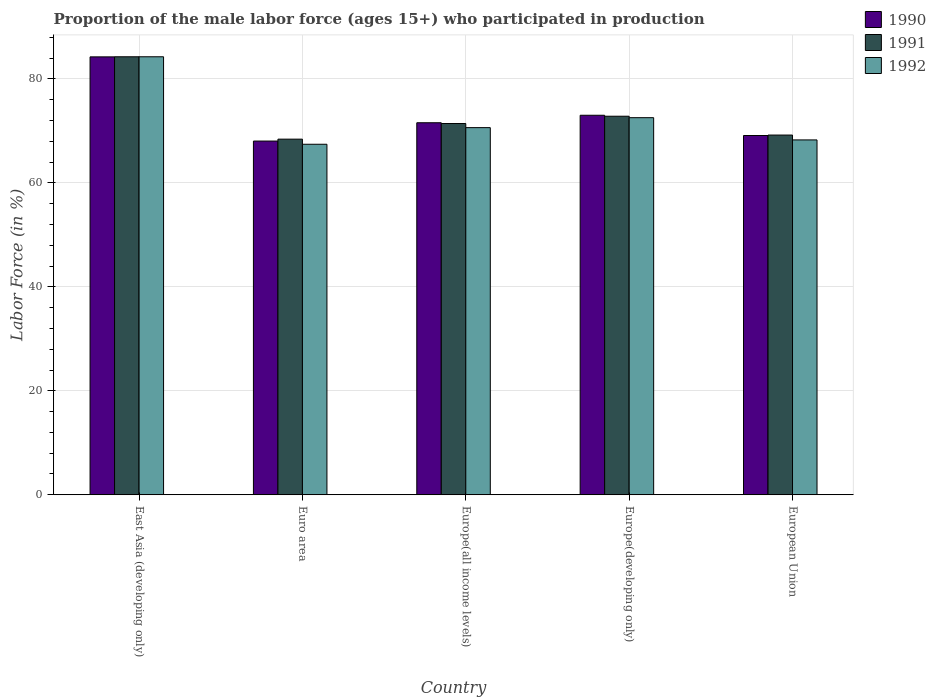How many groups of bars are there?
Your answer should be very brief. 5. How many bars are there on the 2nd tick from the left?
Offer a terse response. 3. What is the label of the 5th group of bars from the left?
Give a very brief answer. European Union. In how many cases, is the number of bars for a given country not equal to the number of legend labels?
Keep it short and to the point. 0. What is the proportion of the male labor force who participated in production in 1990 in Europe(all income levels)?
Provide a succinct answer. 71.56. Across all countries, what is the maximum proportion of the male labor force who participated in production in 1990?
Make the answer very short. 84.23. Across all countries, what is the minimum proportion of the male labor force who participated in production in 1992?
Offer a terse response. 67.42. In which country was the proportion of the male labor force who participated in production in 1990 maximum?
Your answer should be compact. East Asia (developing only). What is the total proportion of the male labor force who participated in production in 1991 in the graph?
Make the answer very short. 366.07. What is the difference between the proportion of the male labor force who participated in production in 1991 in Euro area and that in European Union?
Provide a short and direct response. -0.79. What is the difference between the proportion of the male labor force who participated in production in 1992 in East Asia (developing only) and the proportion of the male labor force who participated in production in 1990 in Euro area?
Your response must be concise. 16.21. What is the average proportion of the male labor force who participated in production in 1992 per country?
Ensure brevity in your answer.  72.62. What is the difference between the proportion of the male labor force who participated in production of/in 1990 and proportion of the male labor force who participated in production of/in 1992 in European Union?
Offer a very short reply. 0.85. In how many countries, is the proportion of the male labor force who participated in production in 1991 greater than 76 %?
Give a very brief answer. 1. What is the ratio of the proportion of the male labor force who participated in production in 1992 in East Asia (developing only) to that in Europe(all income levels)?
Your response must be concise. 1.19. What is the difference between the highest and the second highest proportion of the male labor force who participated in production in 1990?
Your response must be concise. -11.23. What is the difference between the highest and the lowest proportion of the male labor force who participated in production in 1992?
Offer a very short reply. 16.83. In how many countries, is the proportion of the male labor force who participated in production in 1990 greater than the average proportion of the male labor force who participated in production in 1990 taken over all countries?
Give a very brief answer. 1. Is the sum of the proportion of the male labor force who participated in production in 1991 in East Asia (developing only) and Euro area greater than the maximum proportion of the male labor force who participated in production in 1992 across all countries?
Provide a succinct answer. Yes. Is it the case that in every country, the sum of the proportion of the male labor force who participated in production in 1991 and proportion of the male labor force who participated in production in 1992 is greater than the proportion of the male labor force who participated in production in 1990?
Offer a very short reply. Yes. How many bars are there?
Keep it short and to the point. 15. Are all the bars in the graph horizontal?
Offer a terse response. No. What is the difference between two consecutive major ticks on the Y-axis?
Your answer should be compact. 20. Are the values on the major ticks of Y-axis written in scientific E-notation?
Offer a terse response. No. Does the graph contain grids?
Make the answer very short. Yes. How are the legend labels stacked?
Offer a terse response. Vertical. What is the title of the graph?
Offer a very short reply. Proportion of the male labor force (ages 15+) who participated in production. What is the Labor Force (in %) of 1990 in East Asia (developing only)?
Provide a short and direct response. 84.23. What is the Labor Force (in %) of 1991 in East Asia (developing only)?
Offer a very short reply. 84.25. What is the Labor Force (in %) of 1992 in East Asia (developing only)?
Offer a very short reply. 84.25. What is the Labor Force (in %) of 1990 in Euro area?
Offer a very short reply. 68.04. What is the Labor Force (in %) of 1991 in Euro area?
Your answer should be very brief. 68.4. What is the Labor Force (in %) of 1992 in Euro area?
Offer a very short reply. 67.42. What is the Labor Force (in %) of 1990 in Europe(all income levels)?
Offer a very short reply. 71.56. What is the Labor Force (in %) of 1991 in Europe(all income levels)?
Offer a very short reply. 71.41. What is the Labor Force (in %) of 1992 in Europe(all income levels)?
Your answer should be compact. 70.62. What is the Labor Force (in %) of 1990 in Europe(developing only)?
Make the answer very short. 73. What is the Labor Force (in %) of 1991 in Europe(developing only)?
Offer a terse response. 72.82. What is the Labor Force (in %) in 1992 in Europe(developing only)?
Ensure brevity in your answer.  72.53. What is the Labor Force (in %) of 1990 in European Union?
Your response must be concise. 69.1. What is the Labor Force (in %) of 1991 in European Union?
Ensure brevity in your answer.  69.19. What is the Labor Force (in %) in 1992 in European Union?
Give a very brief answer. 68.26. Across all countries, what is the maximum Labor Force (in %) in 1990?
Your response must be concise. 84.23. Across all countries, what is the maximum Labor Force (in %) of 1991?
Offer a terse response. 84.25. Across all countries, what is the maximum Labor Force (in %) in 1992?
Your answer should be compact. 84.25. Across all countries, what is the minimum Labor Force (in %) of 1990?
Offer a very short reply. 68.04. Across all countries, what is the minimum Labor Force (in %) in 1991?
Ensure brevity in your answer.  68.4. Across all countries, what is the minimum Labor Force (in %) of 1992?
Your answer should be compact. 67.42. What is the total Labor Force (in %) in 1990 in the graph?
Provide a short and direct response. 365.94. What is the total Labor Force (in %) in 1991 in the graph?
Your answer should be compact. 366.07. What is the total Labor Force (in %) in 1992 in the graph?
Make the answer very short. 363.09. What is the difference between the Labor Force (in %) in 1990 in East Asia (developing only) and that in Euro area?
Your answer should be very brief. 16.19. What is the difference between the Labor Force (in %) of 1991 in East Asia (developing only) and that in Euro area?
Keep it short and to the point. 15.84. What is the difference between the Labor Force (in %) of 1992 in East Asia (developing only) and that in Euro area?
Give a very brief answer. 16.83. What is the difference between the Labor Force (in %) in 1990 in East Asia (developing only) and that in Europe(all income levels)?
Provide a short and direct response. 12.67. What is the difference between the Labor Force (in %) in 1991 in East Asia (developing only) and that in Europe(all income levels)?
Make the answer very short. 12.84. What is the difference between the Labor Force (in %) in 1992 in East Asia (developing only) and that in Europe(all income levels)?
Offer a terse response. 13.63. What is the difference between the Labor Force (in %) of 1990 in East Asia (developing only) and that in Europe(developing only)?
Offer a terse response. 11.23. What is the difference between the Labor Force (in %) in 1991 in East Asia (developing only) and that in Europe(developing only)?
Your response must be concise. 11.43. What is the difference between the Labor Force (in %) of 1992 in East Asia (developing only) and that in Europe(developing only)?
Offer a very short reply. 11.71. What is the difference between the Labor Force (in %) in 1990 in East Asia (developing only) and that in European Union?
Give a very brief answer. 15.13. What is the difference between the Labor Force (in %) of 1991 in East Asia (developing only) and that in European Union?
Keep it short and to the point. 15.05. What is the difference between the Labor Force (in %) of 1992 in East Asia (developing only) and that in European Union?
Keep it short and to the point. 15.99. What is the difference between the Labor Force (in %) in 1990 in Euro area and that in Europe(all income levels)?
Give a very brief answer. -3.52. What is the difference between the Labor Force (in %) in 1991 in Euro area and that in Europe(all income levels)?
Your answer should be compact. -3. What is the difference between the Labor Force (in %) of 1992 in Euro area and that in Europe(all income levels)?
Provide a short and direct response. -3.2. What is the difference between the Labor Force (in %) of 1990 in Euro area and that in Europe(developing only)?
Your answer should be very brief. -4.96. What is the difference between the Labor Force (in %) of 1991 in Euro area and that in Europe(developing only)?
Provide a succinct answer. -4.41. What is the difference between the Labor Force (in %) in 1992 in Euro area and that in Europe(developing only)?
Keep it short and to the point. -5.11. What is the difference between the Labor Force (in %) of 1990 in Euro area and that in European Union?
Ensure brevity in your answer.  -1.06. What is the difference between the Labor Force (in %) in 1991 in Euro area and that in European Union?
Offer a very short reply. -0.79. What is the difference between the Labor Force (in %) in 1992 in Euro area and that in European Union?
Offer a very short reply. -0.83. What is the difference between the Labor Force (in %) in 1990 in Europe(all income levels) and that in Europe(developing only)?
Keep it short and to the point. -1.44. What is the difference between the Labor Force (in %) in 1991 in Europe(all income levels) and that in Europe(developing only)?
Make the answer very short. -1.41. What is the difference between the Labor Force (in %) of 1992 in Europe(all income levels) and that in Europe(developing only)?
Keep it short and to the point. -1.91. What is the difference between the Labor Force (in %) of 1990 in Europe(all income levels) and that in European Union?
Offer a very short reply. 2.46. What is the difference between the Labor Force (in %) of 1991 in Europe(all income levels) and that in European Union?
Offer a terse response. 2.22. What is the difference between the Labor Force (in %) of 1992 in Europe(all income levels) and that in European Union?
Give a very brief answer. 2.36. What is the difference between the Labor Force (in %) of 1990 in Europe(developing only) and that in European Union?
Give a very brief answer. 3.9. What is the difference between the Labor Force (in %) in 1991 in Europe(developing only) and that in European Union?
Offer a very short reply. 3.62. What is the difference between the Labor Force (in %) of 1992 in Europe(developing only) and that in European Union?
Your answer should be very brief. 4.28. What is the difference between the Labor Force (in %) in 1990 in East Asia (developing only) and the Labor Force (in %) in 1991 in Euro area?
Ensure brevity in your answer.  15.83. What is the difference between the Labor Force (in %) in 1990 in East Asia (developing only) and the Labor Force (in %) in 1992 in Euro area?
Your answer should be very brief. 16.81. What is the difference between the Labor Force (in %) in 1991 in East Asia (developing only) and the Labor Force (in %) in 1992 in Euro area?
Give a very brief answer. 16.82. What is the difference between the Labor Force (in %) of 1990 in East Asia (developing only) and the Labor Force (in %) of 1991 in Europe(all income levels)?
Offer a very short reply. 12.82. What is the difference between the Labor Force (in %) of 1990 in East Asia (developing only) and the Labor Force (in %) of 1992 in Europe(all income levels)?
Offer a very short reply. 13.61. What is the difference between the Labor Force (in %) of 1991 in East Asia (developing only) and the Labor Force (in %) of 1992 in Europe(all income levels)?
Offer a terse response. 13.63. What is the difference between the Labor Force (in %) in 1990 in East Asia (developing only) and the Labor Force (in %) in 1991 in Europe(developing only)?
Offer a terse response. 11.42. What is the difference between the Labor Force (in %) in 1990 in East Asia (developing only) and the Labor Force (in %) in 1992 in Europe(developing only)?
Offer a terse response. 11.7. What is the difference between the Labor Force (in %) of 1991 in East Asia (developing only) and the Labor Force (in %) of 1992 in Europe(developing only)?
Provide a short and direct response. 11.71. What is the difference between the Labor Force (in %) of 1990 in East Asia (developing only) and the Labor Force (in %) of 1991 in European Union?
Ensure brevity in your answer.  15.04. What is the difference between the Labor Force (in %) of 1990 in East Asia (developing only) and the Labor Force (in %) of 1992 in European Union?
Make the answer very short. 15.97. What is the difference between the Labor Force (in %) in 1991 in East Asia (developing only) and the Labor Force (in %) in 1992 in European Union?
Your response must be concise. 15.99. What is the difference between the Labor Force (in %) of 1990 in Euro area and the Labor Force (in %) of 1991 in Europe(all income levels)?
Offer a terse response. -3.37. What is the difference between the Labor Force (in %) of 1990 in Euro area and the Labor Force (in %) of 1992 in Europe(all income levels)?
Provide a succinct answer. -2.58. What is the difference between the Labor Force (in %) in 1991 in Euro area and the Labor Force (in %) in 1992 in Europe(all income levels)?
Your answer should be compact. -2.22. What is the difference between the Labor Force (in %) in 1990 in Euro area and the Labor Force (in %) in 1991 in Europe(developing only)?
Provide a succinct answer. -4.78. What is the difference between the Labor Force (in %) of 1990 in Euro area and the Labor Force (in %) of 1992 in Europe(developing only)?
Your answer should be compact. -4.49. What is the difference between the Labor Force (in %) of 1991 in Euro area and the Labor Force (in %) of 1992 in Europe(developing only)?
Offer a very short reply. -4.13. What is the difference between the Labor Force (in %) in 1990 in Euro area and the Labor Force (in %) in 1991 in European Union?
Provide a succinct answer. -1.15. What is the difference between the Labor Force (in %) in 1990 in Euro area and the Labor Force (in %) in 1992 in European Union?
Offer a terse response. -0.22. What is the difference between the Labor Force (in %) in 1991 in Euro area and the Labor Force (in %) in 1992 in European Union?
Your answer should be very brief. 0.15. What is the difference between the Labor Force (in %) in 1990 in Europe(all income levels) and the Labor Force (in %) in 1991 in Europe(developing only)?
Provide a short and direct response. -1.26. What is the difference between the Labor Force (in %) of 1990 in Europe(all income levels) and the Labor Force (in %) of 1992 in Europe(developing only)?
Your response must be concise. -0.97. What is the difference between the Labor Force (in %) in 1991 in Europe(all income levels) and the Labor Force (in %) in 1992 in Europe(developing only)?
Make the answer very short. -1.12. What is the difference between the Labor Force (in %) in 1990 in Europe(all income levels) and the Labor Force (in %) in 1991 in European Union?
Make the answer very short. 2.37. What is the difference between the Labor Force (in %) of 1990 in Europe(all income levels) and the Labor Force (in %) of 1992 in European Union?
Your response must be concise. 3.3. What is the difference between the Labor Force (in %) in 1991 in Europe(all income levels) and the Labor Force (in %) in 1992 in European Union?
Your response must be concise. 3.15. What is the difference between the Labor Force (in %) in 1990 in Europe(developing only) and the Labor Force (in %) in 1991 in European Union?
Your response must be concise. 3.81. What is the difference between the Labor Force (in %) of 1990 in Europe(developing only) and the Labor Force (in %) of 1992 in European Union?
Your response must be concise. 4.74. What is the difference between the Labor Force (in %) of 1991 in Europe(developing only) and the Labor Force (in %) of 1992 in European Union?
Keep it short and to the point. 4.56. What is the average Labor Force (in %) of 1990 per country?
Your answer should be compact. 73.19. What is the average Labor Force (in %) of 1991 per country?
Keep it short and to the point. 73.21. What is the average Labor Force (in %) of 1992 per country?
Keep it short and to the point. 72.62. What is the difference between the Labor Force (in %) in 1990 and Labor Force (in %) in 1991 in East Asia (developing only)?
Your answer should be compact. -0.02. What is the difference between the Labor Force (in %) of 1990 and Labor Force (in %) of 1992 in East Asia (developing only)?
Your response must be concise. -0.02. What is the difference between the Labor Force (in %) of 1991 and Labor Force (in %) of 1992 in East Asia (developing only)?
Keep it short and to the point. -0. What is the difference between the Labor Force (in %) of 1990 and Labor Force (in %) of 1991 in Euro area?
Make the answer very short. -0.36. What is the difference between the Labor Force (in %) of 1990 and Labor Force (in %) of 1992 in Euro area?
Offer a terse response. 0.62. What is the difference between the Labor Force (in %) of 1991 and Labor Force (in %) of 1992 in Euro area?
Your response must be concise. 0.98. What is the difference between the Labor Force (in %) of 1990 and Labor Force (in %) of 1991 in Europe(all income levels)?
Provide a short and direct response. 0.15. What is the difference between the Labor Force (in %) of 1990 and Labor Force (in %) of 1992 in Europe(all income levels)?
Give a very brief answer. 0.94. What is the difference between the Labor Force (in %) of 1991 and Labor Force (in %) of 1992 in Europe(all income levels)?
Provide a short and direct response. 0.79. What is the difference between the Labor Force (in %) of 1990 and Labor Force (in %) of 1991 in Europe(developing only)?
Offer a terse response. 0.18. What is the difference between the Labor Force (in %) in 1990 and Labor Force (in %) in 1992 in Europe(developing only)?
Provide a succinct answer. 0.47. What is the difference between the Labor Force (in %) in 1991 and Labor Force (in %) in 1992 in Europe(developing only)?
Make the answer very short. 0.28. What is the difference between the Labor Force (in %) in 1990 and Labor Force (in %) in 1991 in European Union?
Offer a terse response. -0.09. What is the difference between the Labor Force (in %) of 1990 and Labor Force (in %) of 1992 in European Union?
Ensure brevity in your answer.  0.85. What is the difference between the Labor Force (in %) of 1991 and Labor Force (in %) of 1992 in European Union?
Your answer should be compact. 0.93. What is the ratio of the Labor Force (in %) in 1990 in East Asia (developing only) to that in Euro area?
Your answer should be very brief. 1.24. What is the ratio of the Labor Force (in %) of 1991 in East Asia (developing only) to that in Euro area?
Offer a very short reply. 1.23. What is the ratio of the Labor Force (in %) in 1992 in East Asia (developing only) to that in Euro area?
Provide a short and direct response. 1.25. What is the ratio of the Labor Force (in %) in 1990 in East Asia (developing only) to that in Europe(all income levels)?
Offer a very short reply. 1.18. What is the ratio of the Labor Force (in %) in 1991 in East Asia (developing only) to that in Europe(all income levels)?
Make the answer very short. 1.18. What is the ratio of the Labor Force (in %) of 1992 in East Asia (developing only) to that in Europe(all income levels)?
Provide a short and direct response. 1.19. What is the ratio of the Labor Force (in %) of 1990 in East Asia (developing only) to that in Europe(developing only)?
Your response must be concise. 1.15. What is the ratio of the Labor Force (in %) of 1991 in East Asia (developing only) to that in Europe(developing only)?
Provide a succinct answer. 1.16. What is the ratio of the Labor Force (in %) in 1992 in East Asia (developing only) to that in Europe(developing only)?
Your response must be concise. 1.16. What is the ratio of the Labor Force (in %) of 1990 in East Asia (developing only) to that in European Union?
Your answer should be very brief. 1.22. What is the ratio of the Labor Force (in %) in 1991 in East Asia (developing only) to that in European Union?
Ensure brevity in your answer.  1.22. What is the ratio of the Labor Force (in %) of 1992 in East Asia (developing only) to that in European Union?
Your answer should be compact. 1.23. What is the ratio of the Labor Force (in %) of 1990 in Euro area to that in Europe(all income levels)?
Give a very brief answer. 0.95. What is the ratio of the Labor Force (in %) in 1991 in Euro area to that in Europe(all income levels)?
Your response must be concise. 0.96. What is the ratio of the Labor Force (in %) of 1992 in Euro area to that in Europe(all income levels)?
Provide a succinct answer. 0.95. What is the ratio of the Labor Force (in %) of 1990 in Euro area to that in Europe(developing only)?
Your answer should be compact. 0.93. What is the ratio of the Labor Force (in %) in 1991 in Euro area to that in Europe(developing only)?
Ensure brevity in your answer.  0.94. What is the ratio of the Labor Force (in %) in 1992 in Euro area to that in Europe(developing only)?
Your answer should be compact. 0.93. What is the ratio of the Labor Force (in %) in 1990 in Euro area to that in European Union?
Provide a short and direct response. 0.98. What is the ratio of the Labor Force (in %) in 1991 in Euro area to that in European Union?
Provide a succinct answer. 0.99. What is the ratio of the Labor Force (in %) of 1992 in Euro area to that in European Union?
Provide a succinct answer. 0.99. What is the ratio of the Labor Force (in %) of 1990 in Europe(all income levels) to that in Europe(developing only)?
Provide a succinct answer. 0.98. What is the ratio of the Labor Force (in %) of 1991 in Europe(all income levels) to that in Europe(developing only)?
Make the answer very short. 0.98. What is the ratio of the Labor Force (in %) in 1992 in Europe(all income levels) to that in Europe(developing only)?
Make the answer very short. 0.97. What is the ratio of the Labor Force (in %) of 1990 in Europe(all income levels) to that in European Union?
Offer a very short reply. 1.04. What is the ratio of the Labor Force (in %) of 1991 in Europe(all income levels) to that in European Union?
Offer a very short reply. 1.03. What is the ratio of the Labor Force (in %) in 1992 in Europe(all income levels) to that in European Union?
Make the answer very short. 1.03. What is the ratio of the Labor Force (in %) in 1990 in Europe(developing only) to that in European Union?
Provide a succinct answer. 1.06. What is the ratio of the Labor Force (in %) of 1991 in Europe(developing only) to that in European Union?
Provide a succinct answer. 1.05. What is the ratio of the Labor Force (in %) of 1992 in Europe(developing only) to that in European Union?
Your answer should be very brief. 1.06. What is the difference between the highest and the second highest Labor Force (in %) of 1990?
Provide a short and direct response. 11.23. What is the difference between the highest and the second highest Labor Force (in %) in 1991?
Your answer should be compact. 11.43. What is the difference between the highest and the second highest Labor Force (in %) of 1992?
Give a very brief answer. 11.71. What is the difference between the highest and the lowest Labor Force (in %) of 1990?
Ensure brevity in your answer.  16.19. What is the difference between the highest and the lowest Labor Force (in %) in 1991?
Ensure brevity in your answer.  15.84. What is the difference between the highest and the lowest Labor Force (in %) in 1992?
Provide a succinct answer. 16.83. 